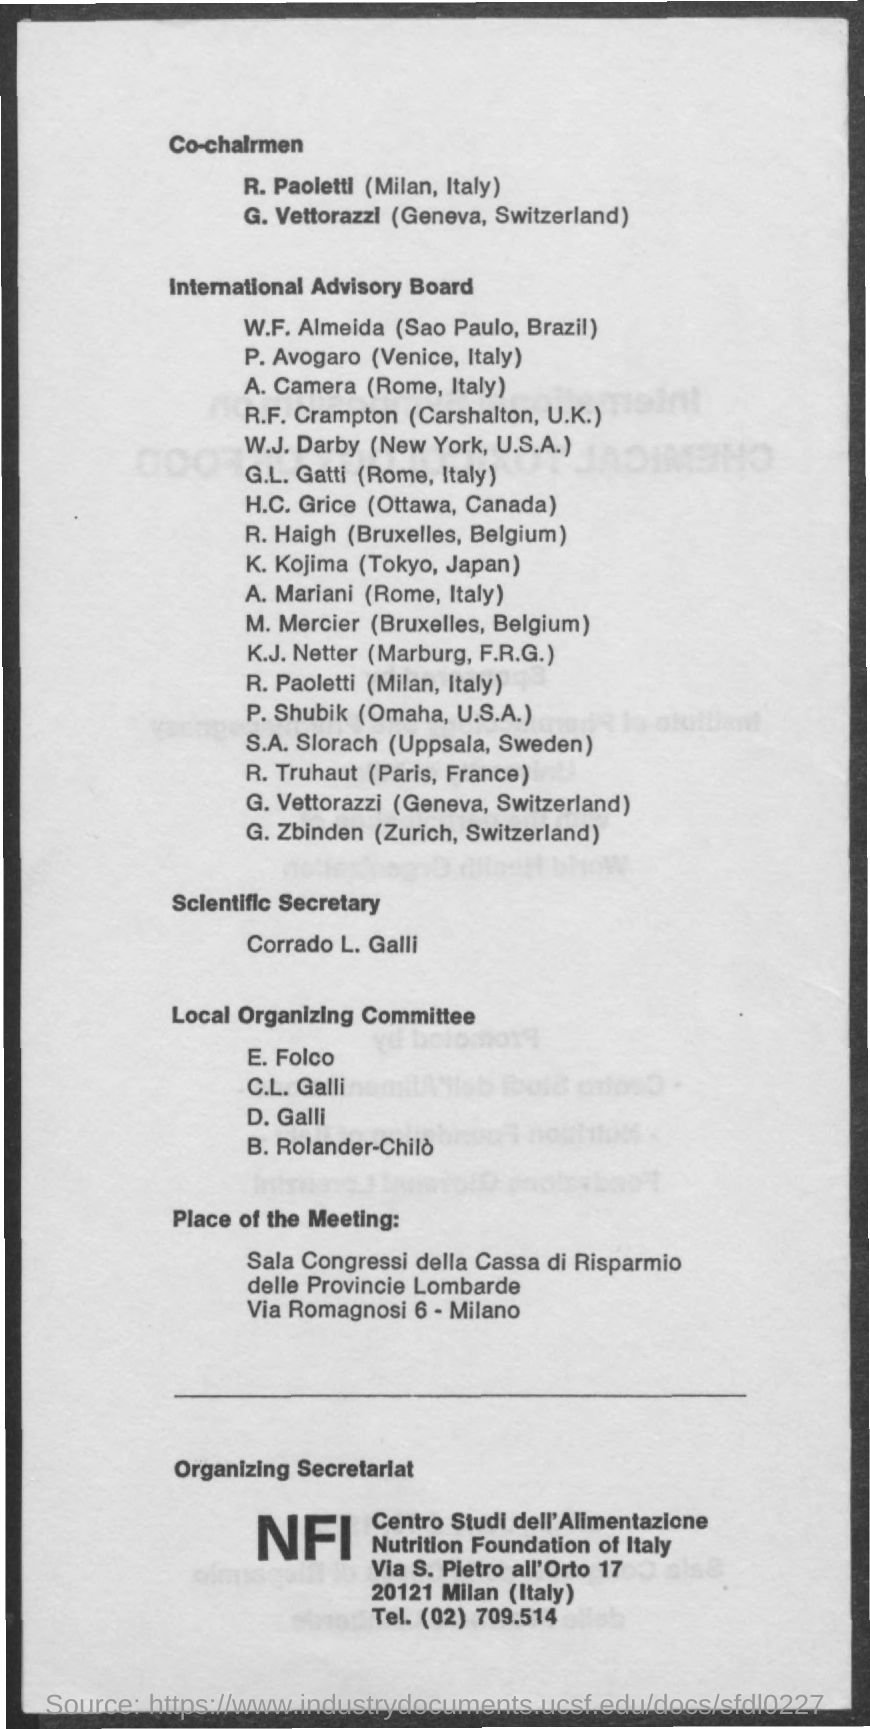Draw attention to some important aspects in this diagram. The telephone number mentioned in the document is (02) 709.514... K. Kojima, a member of the International Advisory Board from Tokyo, Japan, is... The full form of NFI is Nutrition Foundation of Italy. The Scientific Secretary, according to the document, is Corrado L. Galli. 